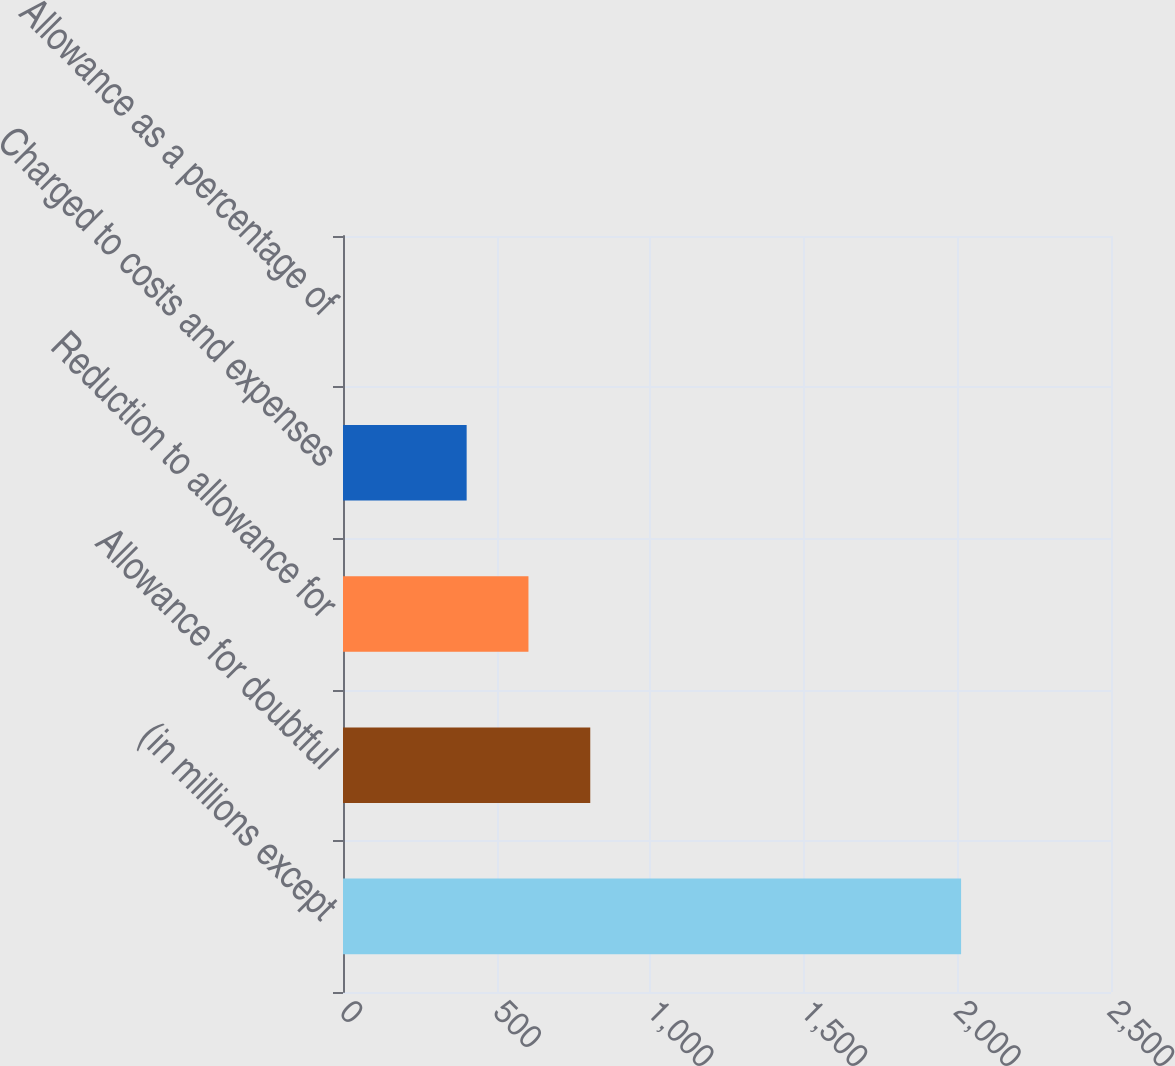Convert chart to OTSL. <chart><loc_0><loc_0><loc_500><loc_500><bar_chart><fcel>(in millions except<fcel>Allowance for doubtful<fcel>Reduction to allowance for<fcel>Charged to costs and expenses<fcel>Allowance as a percentage of<nl><fcel>2012<fcel>804.89<fcel>603.7<fcel>402.51<fcel>0.13<nl></chart> 